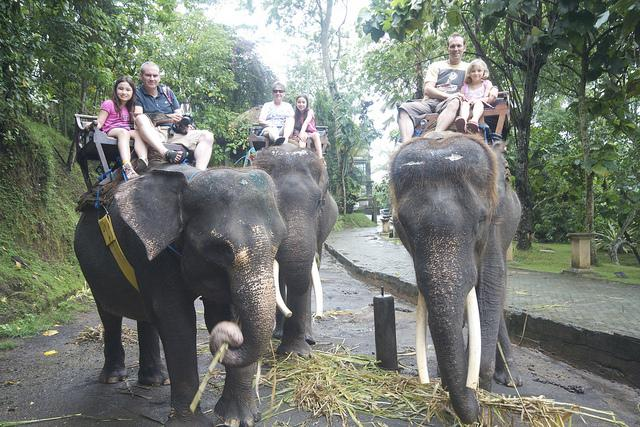How many elephants are standing in the road with people on their backs? Please explain your reasoning. three. You can see three elephants and they are all carrying passengers. 